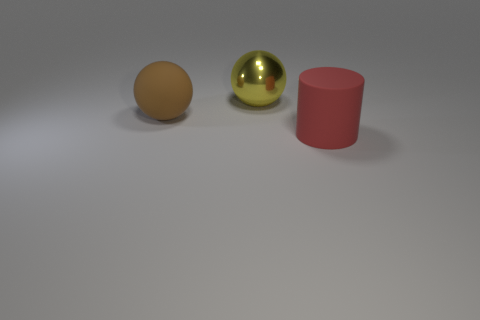Is there another tiny thing that has the same shape as the red thing?
Your answer should be compact. No. Is the shape of the big red thing the same as the large brown thing?
Provide a short and direct response. No. What color is the big thing on the left side of the yellow sphere to the right of the brown rubber sphere?
Offer a terse response. Brown. The matte sphere that is the same size as the yellow thing is what color?
Give a very brief answer. Brown. What number of rubber things are either large red objects or spheres?
Offer a very short reply. 2. There is a ball that is left of the large yellow thing; what number of red rubber cylinders are on the right side of it?
Your response must be concise. 1. How many objects are big brown rubber balls or big spheres that are to the left of the large metallic object?
Your response must be concise. 1. Is there another ball that has the same material as the big brown sphere?
Your response must be concise. No. What number of big objects are both behind the large matte ball and in front of the large yellow sphere?
Your answer should be very brief. 0. What material is the big sphere that is in front of the metal sphere?
Make the answer very short. Rubber. 